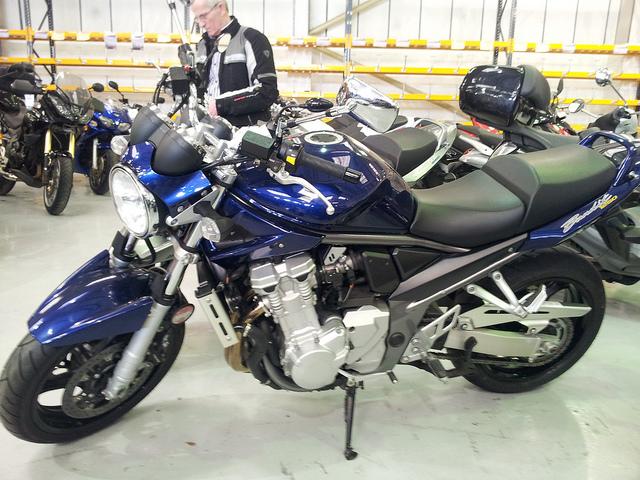How many people can be seen?
Write a very short answer. 1. What type of license do you need to drive this vehicle?
Be succinct. Motorcycle. What kind of floor is pictured?
Short answer required. Concrete. 